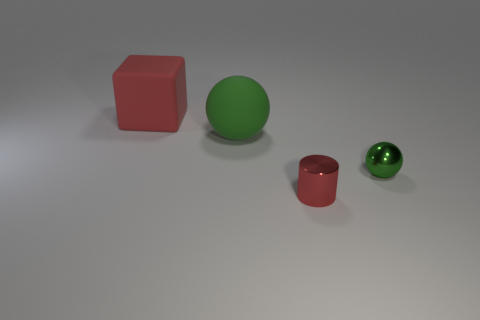There is another green thing that is the same shape as the green rubber thing; what is its material?
Give a very brief answer. Metal. Is the metallic sphere the same color as the large sphere?
Keep it short and to the point. Yes. There is a large object that is the same material as the cube; what shape is it?
Make the answer very short. Sphere. What number of green shiny objects are the same shape as the big red matte thing?
Your response must be concise. 0. The green object right of the metal object that is in front of the small shiny sphere is what shape?
Your answer should be very brief. Sphere. Is the size of the red thing right of the block the same as the shiny ball?
Provide a short and direct response. Yes. There is a object that is right of the matte cube and left of the red metallic cylinder; what is its size?
Your answer should be compact. Large. How many other red matte objects have the same size as the red matte object?
Your answer should be very brief. 0. What number of big red rubber blocks are behind the sphere to the left of the shiny cylinder?
Your response must be concise. 1. There is a object that is to the right of the shiny cylinder; is it the same color as the large matte sphere?
Give a very brief answer. Yes. 